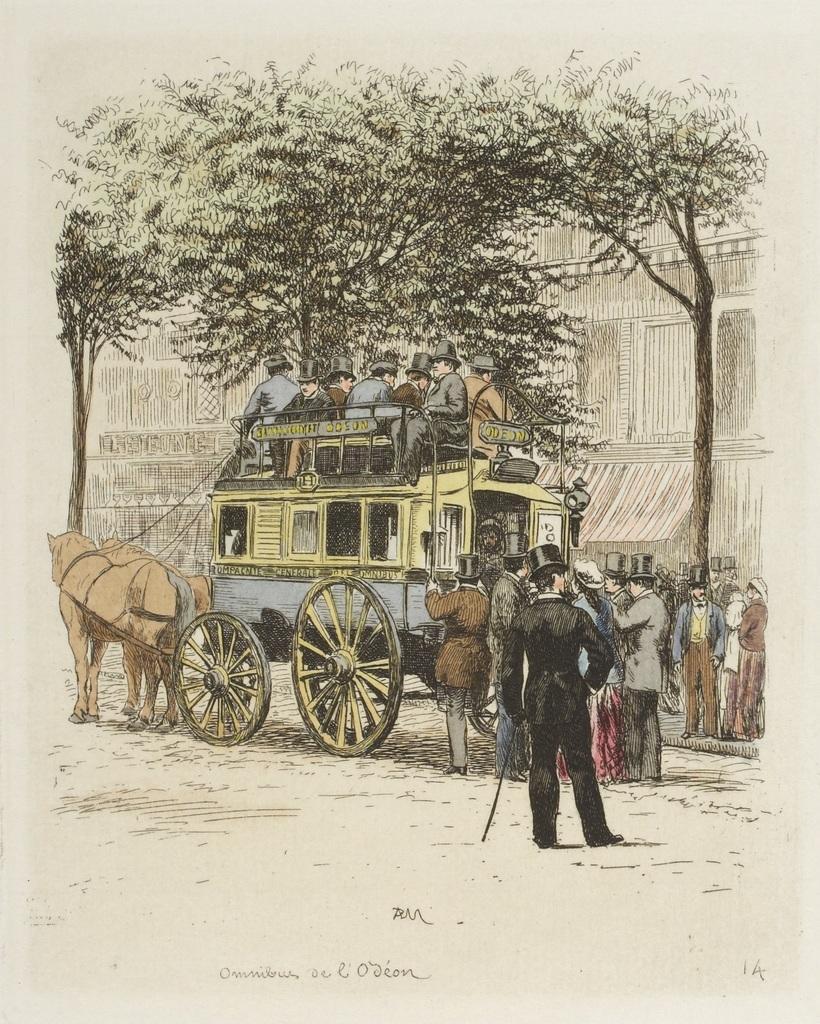Describe this image in one or two sentences. In the picture I can see a painting of a horse cart, two horses, people among them some are standing on the ground and some are sitting on a vehicle. I can also see trees and some other things. Here I can see something written on the image. 